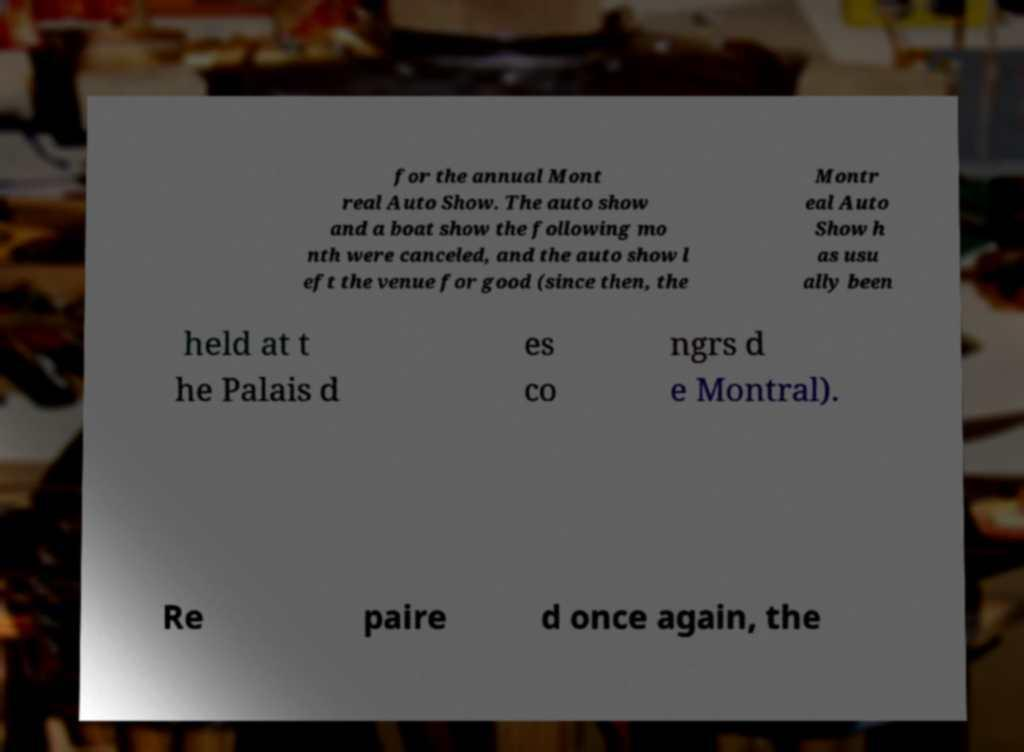Please read and relay the text visible in this image. What does it say? for the annual Mont real Auto Show. The auto show and a boat show the following mo nth were canceled, and the auto show l eft the venue for good (since then, the Montr eal Auto Show h as usu ally been held at t he Palais d es co ngrs d e Montral). Re paire d once again, the 